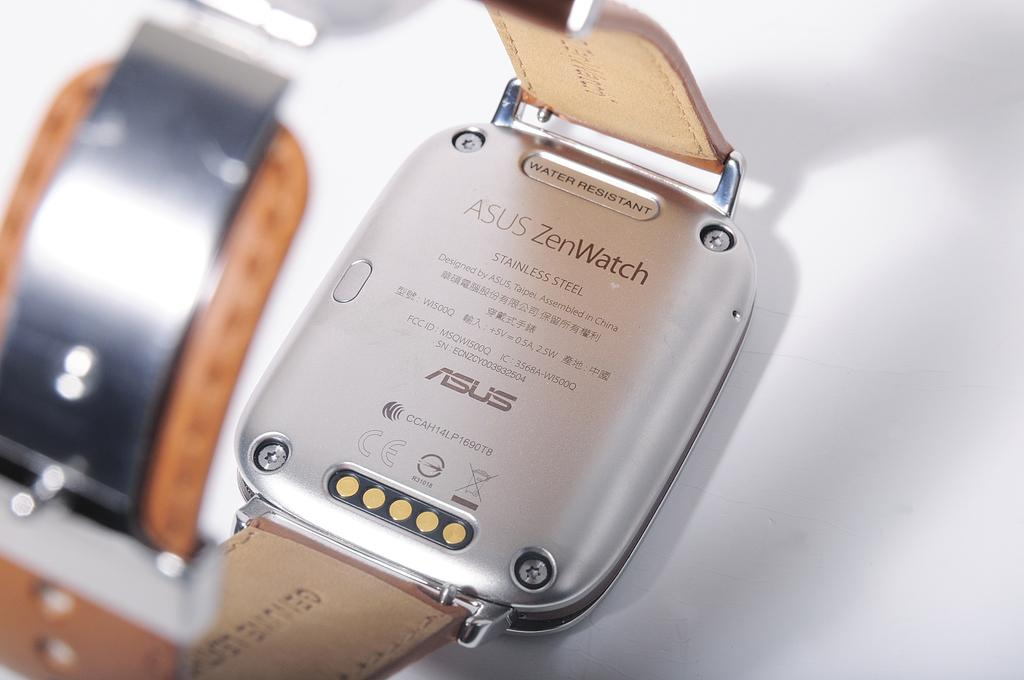<image>
Provide a brief description of the given image. A smartwatch that says Asus ZenWatch has a brown leather band. 